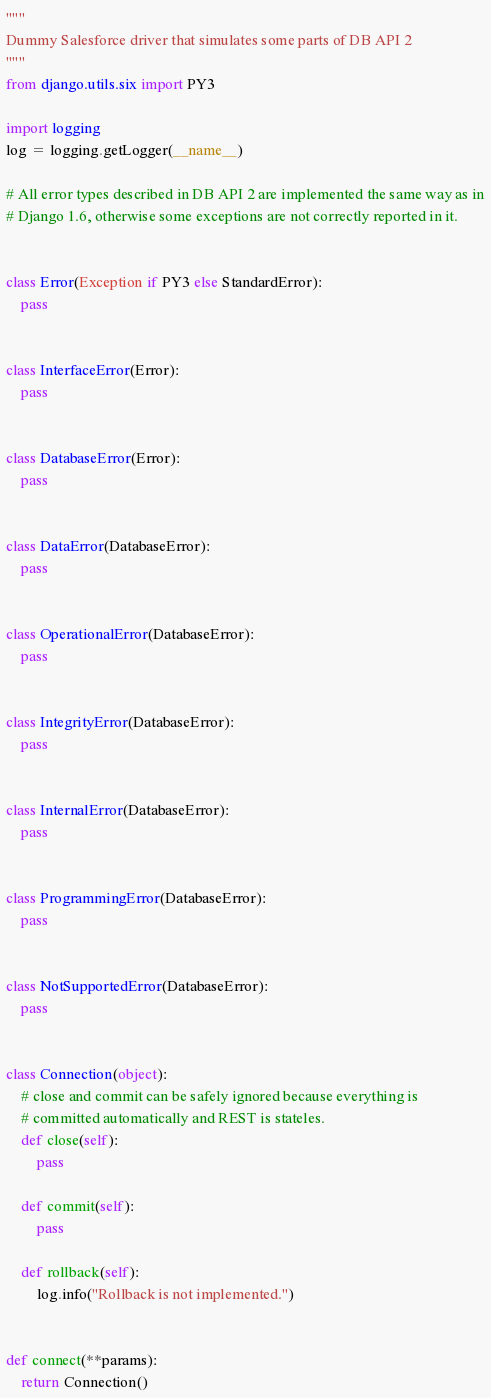<code> <loc_0><loc_0><loc_500><loc_500><_Python_>"""
Dummy Salesforce driver that simulates some parts of DB API 2
"""
from django.utils.six import PY3

import logging
log = logging.getLogger(__name__)

# All error types described in DB API 2 are implemented the same way as in
# Django 1.6, otherwise some exceptions are not correctly reported in it.


class Error(Exception if PY3 else StandardError):
    pass


class InterfaceError(Error):
    pass


class DatabaseError(Error):
    pass


class DataError(DatabaseError):
    pass


class OperationalError(DatabaseError):
    pass


class IntegrityError(DatabaseError):
    pass


class InternalError(DatabaseError):
    pass


class ProgrammingError(DatabaseError):
    pass


class NotSupportedError(DatabaseError):
    pass


class Connection(object):
    # close and commit can be safely ignored because everything is
    # committed automatically and REST is stateles.
    def close(self):
        pass

    def commit(self):
        pass

    def rollback(self):
        log.info("Rollback is not implemented.")


def connect(**params):
    return Connection()
</code> 